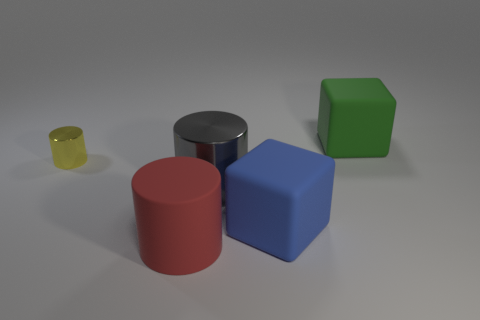Does the yellow thing have the same shape as the gray thing?
Ensure brevity in your answer.  Yes. How many small objects are either gray spheres or green blocks?
Your response must be concise. 0. What color is the small cylinder that is made of the same material as the gray thing?
Your answer should be very brief. Yellow. How many big red cylinders have the same material as the big blue cube?
Offer a very short reply. 1. Does the yellow shiny object that is on the left side of the large metallic thing have the same size as the cylinder on the right side of the red matte cylinder?
Keep it short and to the point. No. What material is the big object that is to the right of the matte cube in front of the large green rubber thing?
Give a very brief answer. Rubber. Are there fewer big matte objects that are to the right of the large gray object than green things in front of the tiny shiny object?
Keep it short and to the point. No. Are there any other things that have the same shape as the large blue object?
Offer a terse response. Yes. What material is the large block behind the yellow shiny object?
Your response must be concise. Rubber. Is there anything else that has the same size as the green matte object?
Provide a short and direct response. Yes. 